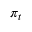Convert formula to latex. <formula><loc_0><loc_0><loc_500><loc_500>\, \pi _ { t }</formula> 